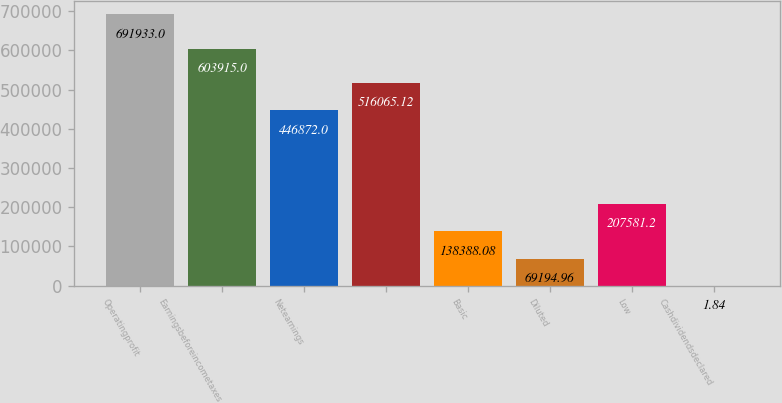Convert chart to OTSL. <chart><loc_0><loc_0><loc_500><loc_500><bar_chart><fcel>Operatingprofit<fcel>Earningsbeforeincometaxes<fcel>Netearnings<fcel>Unnamed: 3<fcel>Basic<fcel>Diluted<fcel>Low<fcel>Cashdividendsdeclared<nl><fcel>691933<fcel>603915<fcel>446872<fcel>516065<fcel>138388<fcel>69195<fcel>207581<fcel>1.84<nl></chart> 